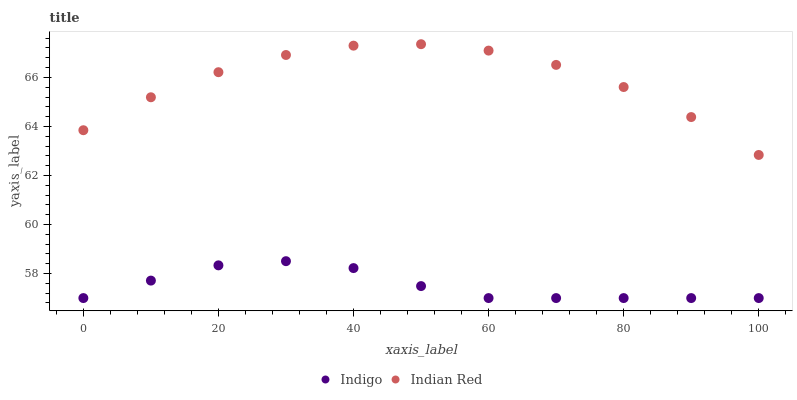Does Indigo have the minimum area under the curve?
Answer yes or no. Yes. Does Indian Red have the maximum area under the curve?
Answer yes or no. Yes. Does Indian Red have the minimum area under the curve?
Answer yes or no. No. Is Indigo the smoothest?
Answer yes or no. Yes. Is Indian Red the roughest?
Answer yes or no. Yes. Is Indian Red the smoothest?
Answer yes or no. No. Does Indigo have the lowest value?
Answer yes or no. Yes. Does Indian Red have the lowest value?
Answer yes or no. No. Does Indian Red have the highest value?
Answer yes or no. Yes. Is Indigo less than Indian Red?
Answer yes or no. Yes. Is Indian Red greater than Indigo?
Answer yes or no. Yes. Does Indigo intersect Indian Red?
Answer yes or no. No. 